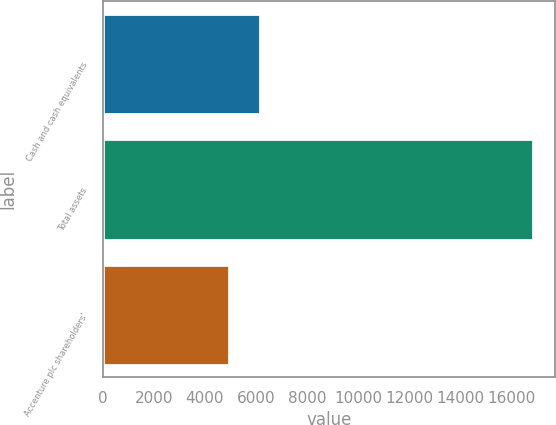Convert chart. <chart><loc_0><loc_0><loc_500><loc_500><bar_chart><fcel>Cash and cash equivalents<fcel>Total assets<fcel>Accenture plc shareholders'<nl><fcel>6150.7<fcel>16867<fcel>4960<nl></chart> 